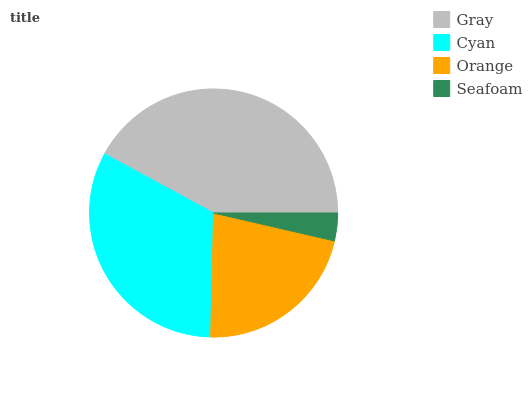Is Seafoam the minimum?
Answer yes or no. Yes. Is Gray the maximum?
Answer yes or no. Yes. Is Cyan the minimum?
Answer yes or no. No. Is Cyan the maximum?
Answer yes or no. No. Is Gray greater than Cyan?
Answer yes or no. Yes. Is Cyan less than Gray?
Answer yes or no. Yes. Is Cyan greater than Gray?
Answer yes or no. No. Is Gray less than Cyan?
Answer yes or no. No. Is Cyan the high median?
Answer yes or no. Yes. Is Orange the low median?
Answer yes or no. Yes. Is Seafoam the high median?
Answer yes or no. No. Is Cyan the low median?
Answer yes or no. No. 